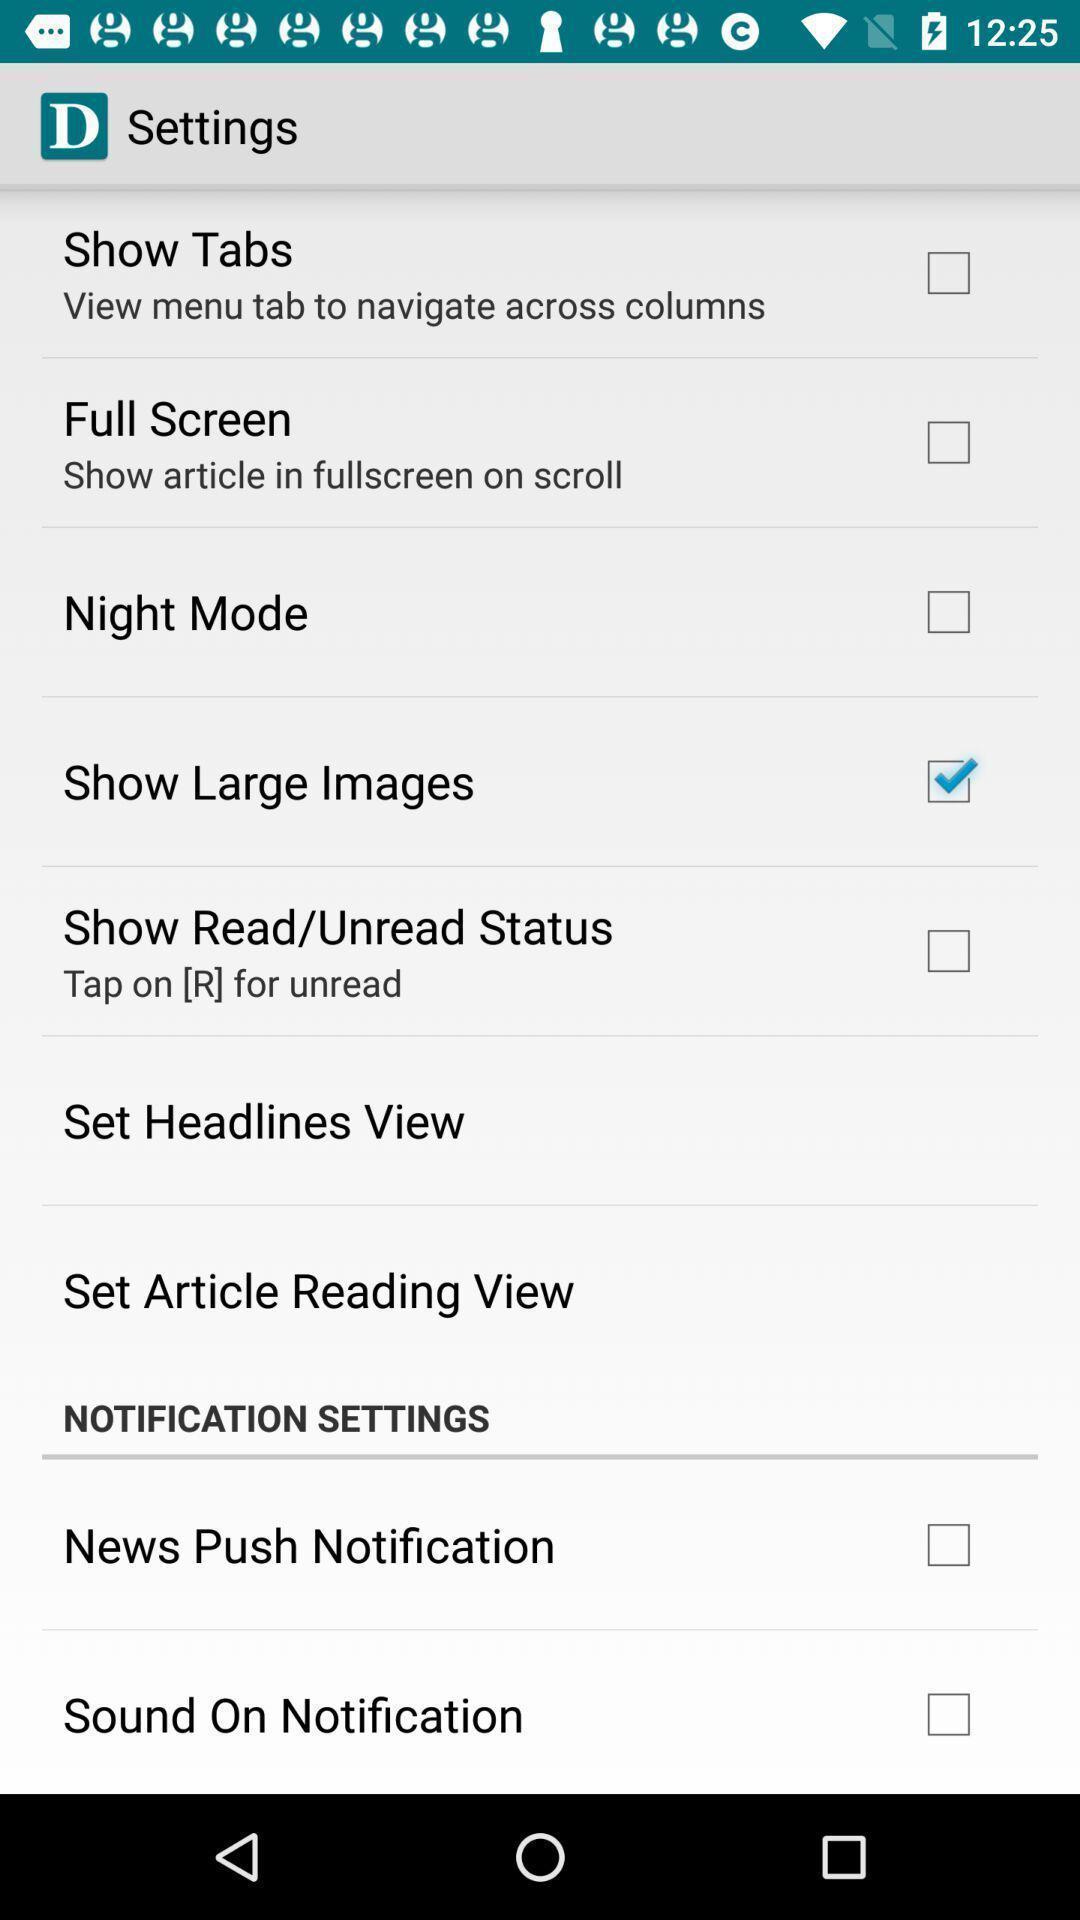Provide a textual representation of this image. Screen displaying multiple setting options. 